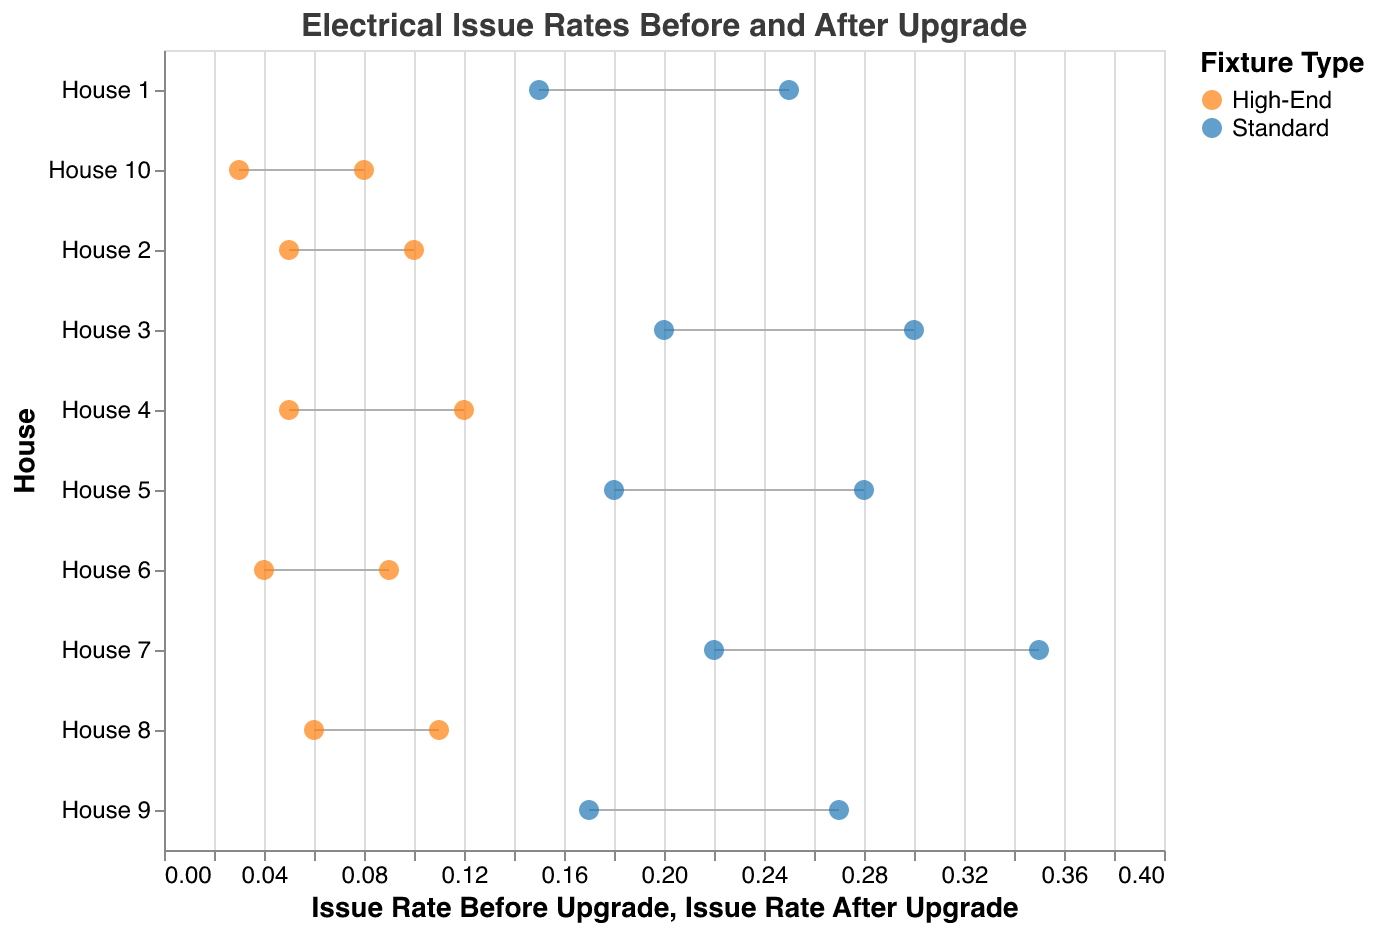What is the title of the figure? The title of the figure is prominently displayed at the top and reads "Electrical Issue Rates Before and After Upgrade".
Answer: Electrical Issue Rates Before and After Upgrade How many houses are represented in the figure? By examining the number of unique labels on the y-axis, we can see that there are 10 houses represented in the figure.
Answer: 10 Which house had the highest issue rate before the upgrade and what was it? By looking at the x-axis values for the point farthest to the right in the "Issue Rate Before Upgrade" series, we can identify that House 7 had the highest issue rate before the upgrade, which was 0.35.
Answer: House 7, 0.35 What is the difference in issue rates before and after the upgrade for House 4? The issue rate before the upgrade for House 4 was 0.12, and after the upgrade, it was 0.05. The difference is calculated as 0.12 - 0.05.
Answer: 0.07 Which type of fixture showed the largest improvement in issue rate after the upgrade? To find the type of fixture with the largest improvement, we need to compare the differences between the "Issue Rate Before Upgrade" and "Issue Rate After Upgrade" for both fixture types. High-End fixtures generally have smaller values on the x-axis after the upgrade, indicating a significant improvement.
Answer: High-End What is the average issue rate before the upgrade for houses with Standard fixtures? Standard fixtures before upgrade include House 1 (0.25), House 3 (0.30), House 5 (0.28), House 7 (0.35), and House 9 (0.27). The average is calculated as (0.25 + 0.30 + 0.28 + 0.35 + 0.27) / 5.
Answer: 0.29 Is there any house where the issue rate after the upgrade did not show any improvement? To determine this, we need to check if any house has the same value for "Issue Rate Before Upgrade" and "Issue Rate After Upgrade". In the figure, all houses show some degree of improvement since no line is vertical, so no houses meet this criterion.
Answer: No Compare the issue rate before the upgrade for House 6 and House 10. Which house had a lower rate and by how much? The issue rate before the upgrade for House 6 was 0.09, and for House 10, it was 0.08. By comparing these values, House 10 had a lower rate by 0.01.
Answer: House 10, 0.01 Which house experienced the smallest reduction in issue rate after the upgrade? By comparing the length of the lines (difference between "Issue Rate Before Upgrade" and "Issue Rate After Upgrade"), House 8 appears to have the smallest reduction, from 0.11 to 0.06, a difference of 0.05.
Answer: House 8 What is the visual representation used to display issue rates before and after upgrades for each house? The figure uses a Dumbbell Plot where horizontal lines connect two points representing the issue rates before and after upgrade for each house, with each point marked by colors indicating the type of fixture.
Answer: Dumbbell Plot 